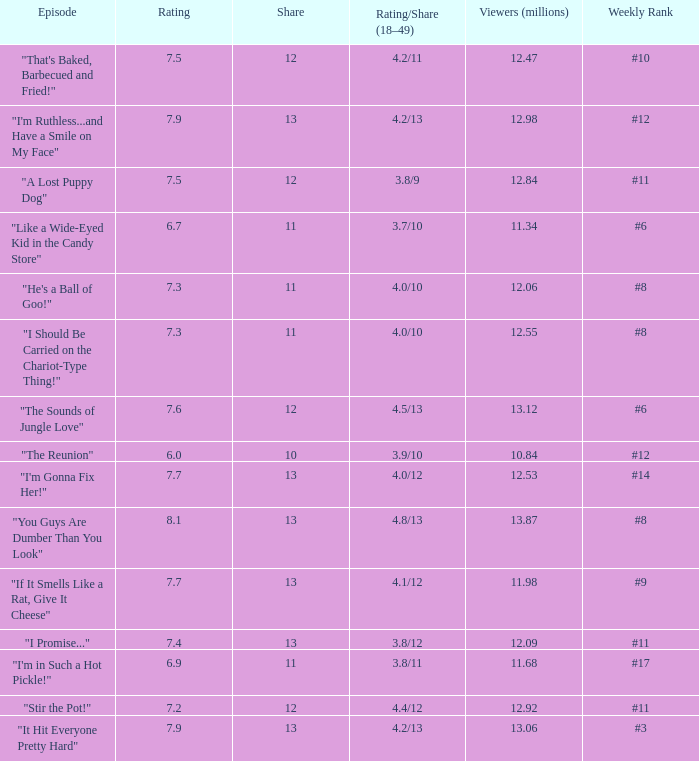Help me parse the entirety of this table. {'header': ['Episode', 'Rating', 'Share', 'Rating/Share (18–49)', 'Viewers (millions)', 'Weekly Rank'], 'rows': [['"That\'s Baked, Barbecued and Fried!"', '7.5', '12', '4.2/11', '12.47', '#10'], ['"I\'m Ruthless...and Have a Smile on My Face"', '7.9', '13', '4.2/13', '12.98', '#12'], ['"A Lost Puppy Dog"', '7.5', '12', '3.8/9', '12.84', '#11'], ['"Like a Wide-Eyed Kid in the Candy Store"', '6.7', '11', '3.7/10', '11.34', '#6'], ['"He\'s a Ball of Goo!"', '7.3', '11', '4.0/10', '12.06', '#8'], ['"I Should Be Carried on the Chariot-Type Thing!"', '7.3', '11', '4.0/10', '12.55', '#8'], ['"The Sounds of Jungle Love"', '7.6', '12', '4.5/13', '13.12', '#6'], ['"The Reunion"', '6.0', '10', '3.9/10', '10.84', '#12'], ['"I\'m Gonna Fix Her!"', '7.7', '13', '4.0/12', '12.53', '#14'], ['"You Guys Are Dumber Than You Look"', '8.1', '13', '4.8/13', '13.87', '#8'], ['"If It Smells Like a Rat, Give It Cheese"', '7.7', '13', '4.1/12', '11.98', '#9'], ['"I Promise..."', '7.4', '13', '3.8/12', '12.09', '#11'], ['"I\'m in Such a Hot Pickle!"', '6.9', '11', '3.8/11', '11.68', '#17'], ['"Stir the Pot!"', '7.2', '12', '4.4/12', '12.92', '#11'], ['"It Hit Everyone Pretty Hard"', '7.9', '13', '4.2/13', '13.06', '#3']]} What is the average rating for "a lost puppy dog"? 7.5. 